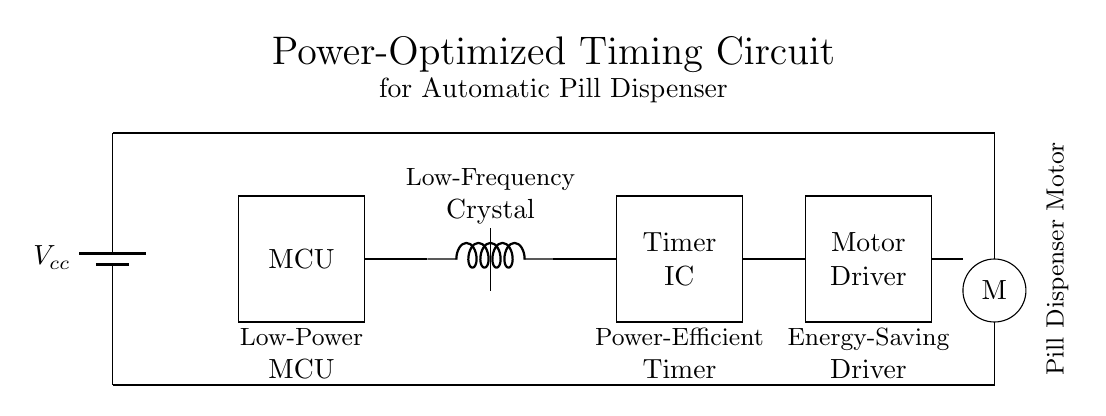What is the main function of the MCU? The MCU, or Microcontroller Unit, coordinates all the tasks in the circuit, including timing operations and activating the motor.
Answer: Timing control What type of oscillator is used in this circuit? The circuit uses a crystal oscillator, which provides a stable clock frequency essential for the microcontroller's timing accuracy.
Answer: Crystal oscillator What component drives the stepper motor? The motor driver controls the stepper motor by translating signals from the microcontroller into actions that move the motor.
Answer: Motor driver How many major components are there in this circuit? There are five major components: the power supply, microcontroller, timer IC, motor driver, and stepper motor.
Answer: Five What is the voltage source for this circuit? The circuit is powered by a battery, denoted as Vcc, which supplies the necessary voltage to operate all components.
Answer: Vcc Why is a low-power timer IC used in this circuit? The low-power timer IC extends battery life by consuming minimal current during operation, making it suitable for portable and energy-efficient devices.
Answer: Battery life What is the purpose of the low-frequency crystal in this circuit? The low-frequency crystal stabilizes the clock signal for the microcontroller, enabling precise timing for the pill dispensing operation.
Answer: Precise timing 